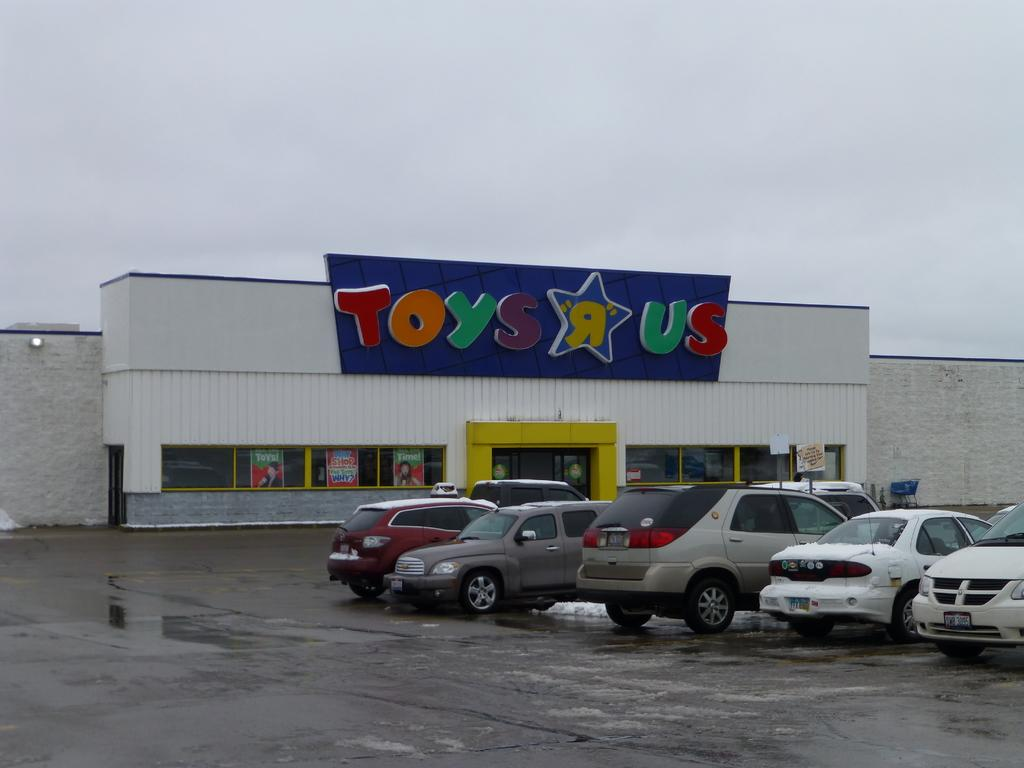What type of establishment is shown in the image? There is a store in the image. Can you describe any text or signage on the store? There is text on the top of the store. What else can be seen in the image besides the store? Vehicles are visible in the image. What is visible in the background of the image? The sky is visible in the image. Where is the sack of potatoes stored in the image? There is no sack of potatoes present in the image. What type of toothpaste is advertised on the store's sign? There is no toothpaste mentioned or advertised on the store's sign in the image. 